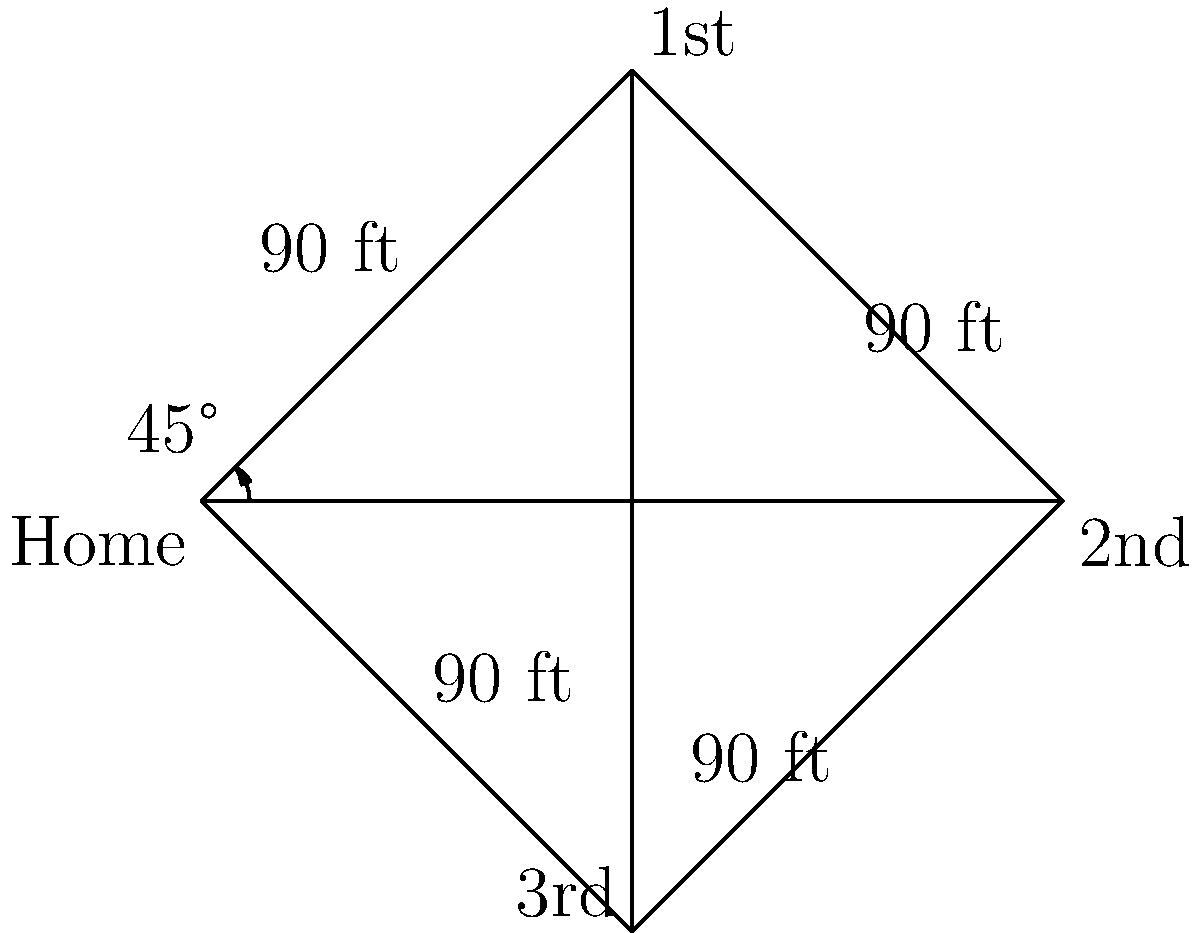At Camden Yards, you're enjoying your lager and notice the perfect symmetry of the baseball diamond. The distance between each base is 90 feet, and the angle between the first base line and the line from home plate to second base is 45°. What is the area of the entire baseball diamond in square feet? Let's approach this step-by-step, Orioles fan!

1) The baseball diamond is a square. We need to find the side length to calculate its area.

2) The diagonal of the square (from home plate to second base) bisects the 90° angle at home plate, creating two 45° angles.

3) This forms a right triangle with the following properties:
   - The hypotenuse is the diagonal of the square
   - One side is half the diagonal (from home to first base), which is 90 feet
   - The angle between these is 45°

4) In a 45-45-90 triangle, the two legs are equal. So if one leg is 90 feet, the hypotenuse must be:

   $$\text{hypotenuse} = 90 \cdot \sqrt{2} \text{ feet}$$

5) This hypotenuse is the diagonal of our square. Let's call the side length of the square $s$. We can use the Pythagorean theorem:

   $$s^2 + s^2 = (90\sqrt{2})^2$$
   $$2s^2 = 16200$$
   $$s^2 = 8100$$
   $$s = 90\sqrt{2} \text{ feet}$$

6) Now that we have the side length, we can calculate the area:

   $$\text{Area} = s^2 = (90\sqrt{2})^2 = 16200 \text{ square feet}$$

So, while you're sipping that cool lager, you now know the Orioles are playing on 16,200 square feet of diamond!
Answer: 16,200 square feet 